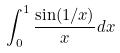<formula> <loc_0><loc_0><loc_500><loc_500>\int _ { 0 } ^ { 1 } \frac { \sin ( 1 / x ) } { x } d x</formula> 